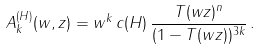Convert formula to latex. <formula><loc_0><loc_0><loc_500><loc_500>A _ { k } ^ { ( H ) } ( w , z ) = w ^ { k } \, c ( H ) \, \frac { T ( w z ) ^ { n } } { ( 1 - T ( w z ) ) ^ { 3 k } } \, .</formula> 